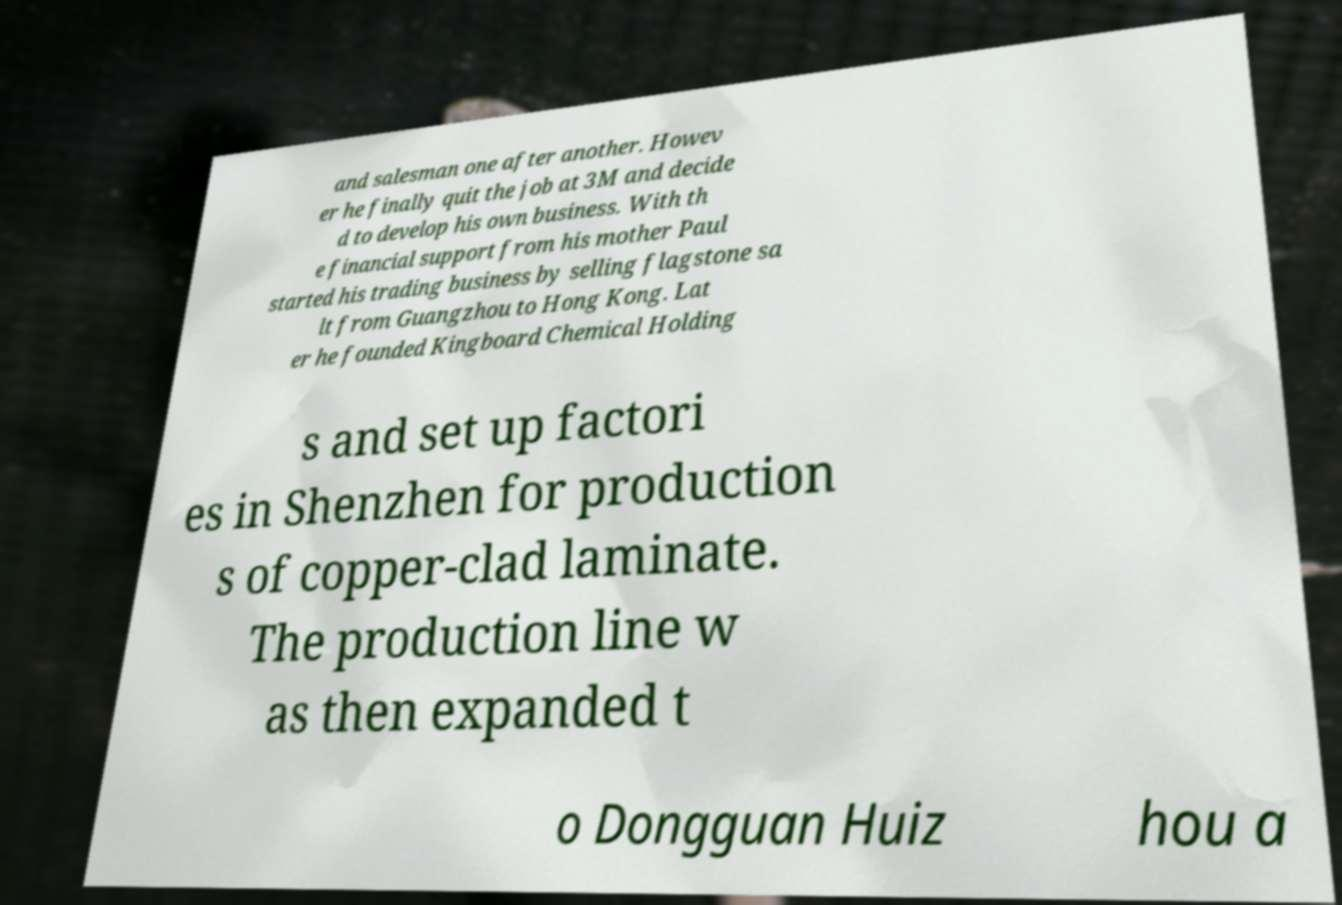Could you extract and type out the text from this image? and salesman one after another. Howev er he finally quit the job at 3M and decide d to develop his own business. With th e financial support from his mother Paul started his trading business by selling flagstone sa lt from Guangzhou to Hong Kong. Lat er he founded Kingboard Chemical Holding s and set up factori es in Shenzhen for production s of copper-clad laminate. The production line w as then expanded t o Dongguan Huiz hou a 